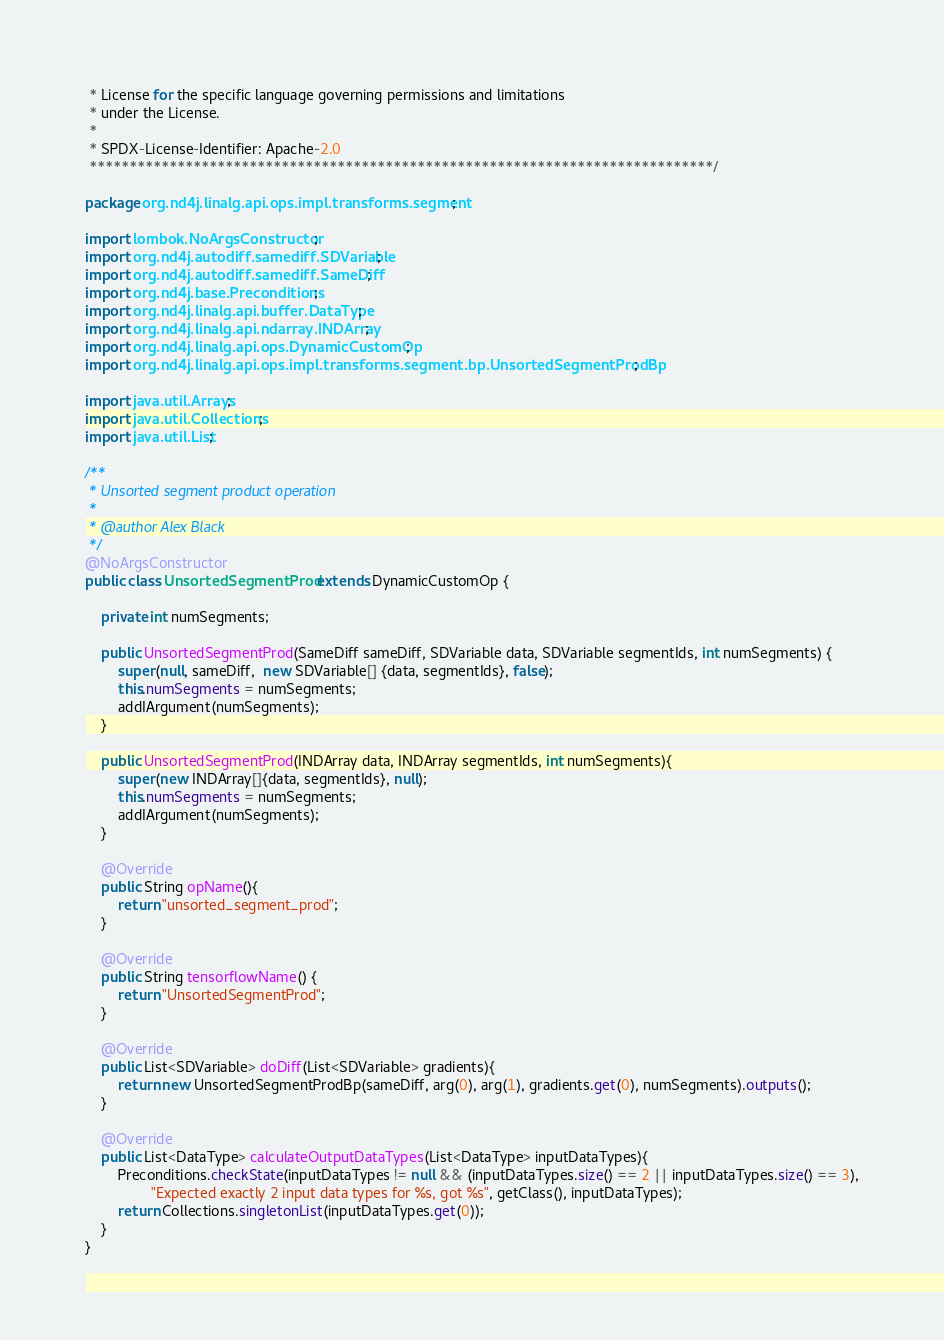<code> <loc_0><loc_0><loc_500><loc_500><_Java_> * License for the specific language governing permissions and limitations
 * under the License.
 *
 * SPDX-License-Identifier: Apache-2.0
 ******************************************************************************/

package org.nd4j.linalg.api.ops.impl.transforms.segment;

import lombok.NoArgsConstructor;
import org.nd4j.autodiff.samediff.SDVariable;
import org.nd4j.autodiff.samediff.SameDiff;
import org.nd4j.base.Preconditions;
import org.nd4j.linalg.api.buffer.DataType;
import org.nd4j.linalg.api.ndarray.INDArray;
import org.nd4j.linalg.api.ops.DynamicCustomOp;
import org.nd4j.linalg.api.ops.impl.transforms.segment.bp.UnsortedSegmentProdBp;

import java.util.Arrays;
import java.util.Collections;
import java.util.List;

/**
 * Unsorted segment product operation
 *
 * @author Alex Black
 */
@NoArgsConstructor
public class UnsortedSegmentProd extends DynamicCustomOp {

    private int numSegments;

    public UnsortedSegmentProd(SameDiff sameDiff, SDVariable data, SDVariable segmentIds, int numSegments) {
        super(null, sameDiff,  new SDVariable[] {data, segmentIds}, false);
        this.numSegments = numSegments;
        addIArgument(numSegments);
    }

    public UnsortedSegmentProd(INDArray data, INDArray segmentIds, int numSegments){
        super(new INDArray[]{data, segmentIds}, null);
        this.numSegments = numSegments;
        addIArgument(numSegments);
    }

    @Override
    public String opName(){
        return "unsorted_segment_prod";
    }

    @Override
    public String tensorflowName() {
        return "UnsortedSegmentProd";
    }

    @Override
    public List<SDVariable> doDiff(List<SDVariable> gradients){
        return new UnsortedSegmentProdBp(sameDiff, arg(0), arg(1), gradients.get(0), numSegments).outputs();
    }

    @Override
    public List<DataType> calculateOutputDataTypes(List<DataType> inputDataTypes){
        Preconditions.checkState(inputDataTypes != null && (inputDataTypes.size() == 2 || inputDataTypes.size() == 3),
                "Expected exactly 2 input data types for %s, got %s", getClass(), inputDataTypes);
        return Collections.singletonList(inputDataTypes.get(0));
    }
}
</code> 